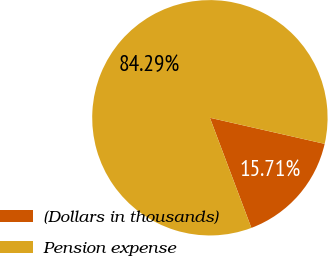Convert chart to OTSL. <chart><loc_0><loc_0><loc_500><loc_500><pie_chart><fcel>(Dollars in thousands)<fcel>Pension expense<nl><fcel>15.71%<fcel>84.29%<nl></chart> 